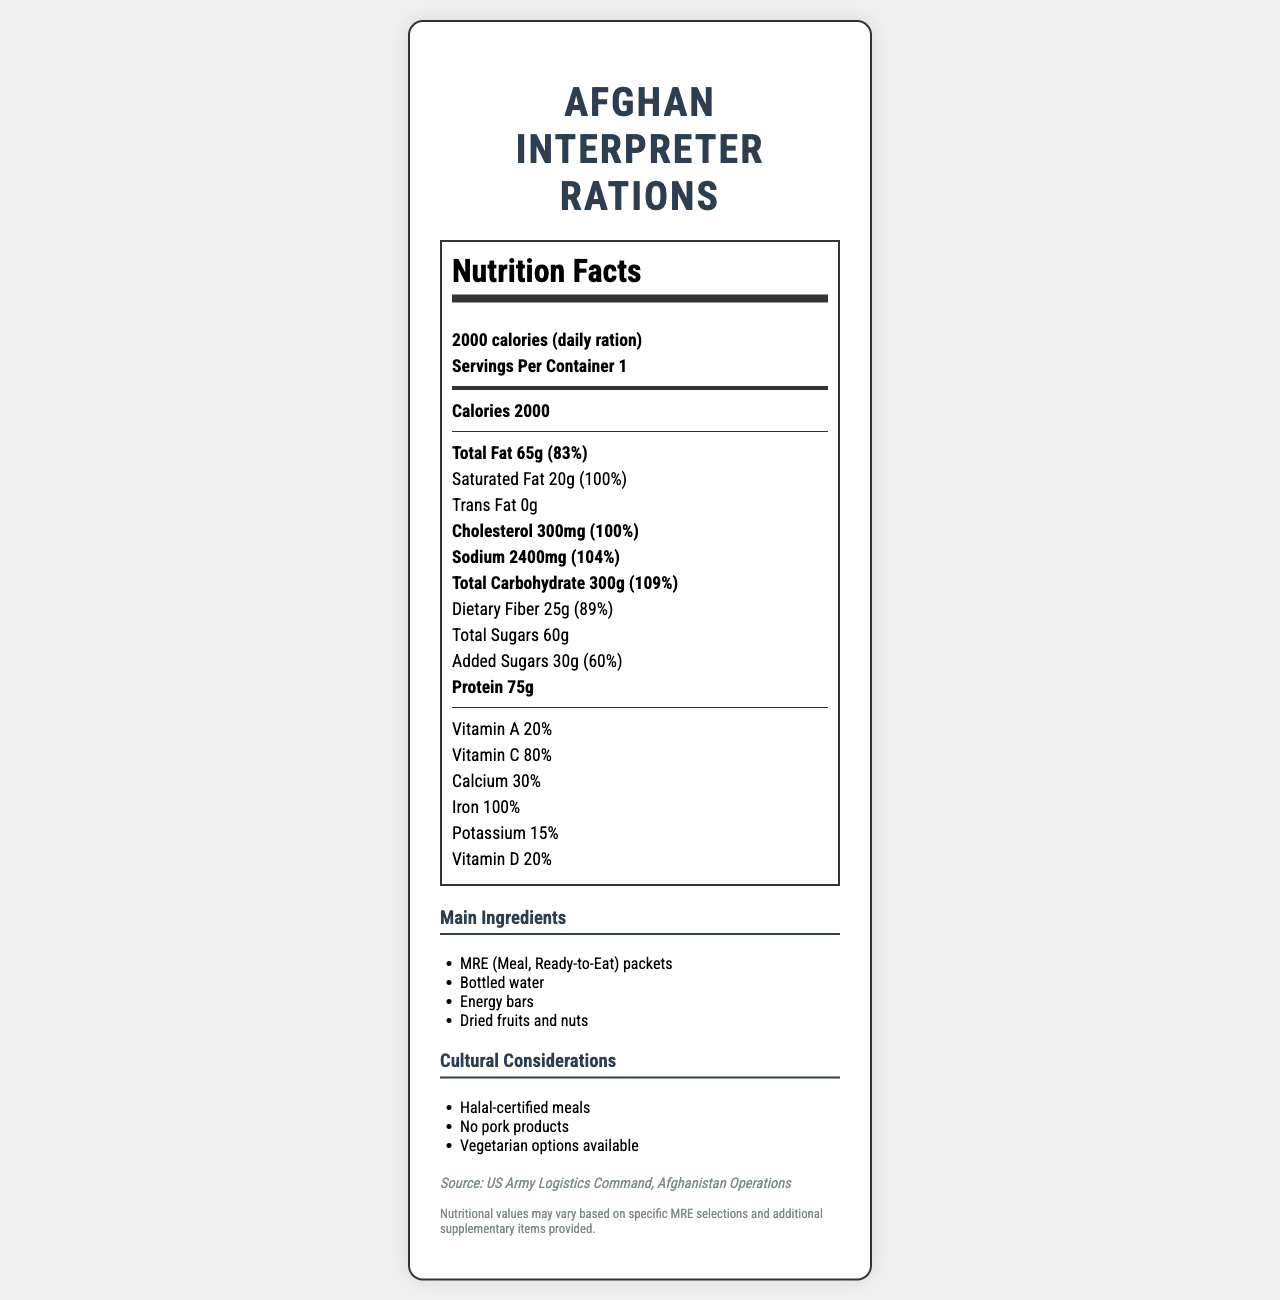what is the serving size? The serving size is clearly mentioned at the top of the nutrition label as "2000 calories (daily ration)".
Answer: 2000 calories (daily ration) how many calories are in one serving? The number of calories per serving is listed as 2000 in the nutrition facts section.
Answer: 2000 what is the percentage of daily value for total fat? The percentage of daily value for total fat is noted as 83% next to the amount of total fat.
Answer: 83% how much protein does the daily ration provide? The amount of protein provided by the daily ration is listed as 75 grams.
Answer: 75g which vitamin has the highest daily value percentage? Vitamin C has the highest daily value percentage, which is 80%.
Answer: Vitamin C what is the amount of total carbohydrate in the daily ration? The total carbohydrate amount is listed as 300 grams.
Answer: 300g which ingredient is not included in the main ingredients list? A. MRE packets B. Bottled water C. Fresh vegetables D. Dried fruits and nuts Fresh vegetables are not listed among the main ingredients; the list includes MRE packets, bottled water, energy bars, and dried fruits and nuts.
Answer: C. Fresh vegetables what cultural consideration has been made regarding dietary restrictions? A. Halal-certified meals B. Organic food C. Gluten-free options The document lists Halal-certified meals as one of the cultural considerations to cater to dietary restrictions.
Answer: A. Halal-certified meals is there any pork product included in the ration? One of the cultural considerations mentioned is "No pork products," indicating it is not included.
Answer: No describe the main idea of this document The document serves as a comprehensive overview of the nutritional and cultural aspects of the rations provided to Afghan interpreters, ensuring that their dietary needs and cultural preferences are met.
Answer: The document provides the nutrition facts for the daily rations provided to Afghan interpreters working with international forces. It details the serving size, caloric content, amounts, and daily percentages of various nutrients, lists the main ingredients, and highlights cultural considerations such as Halal-certified meals, absence of pork products, and vegetarian options. what is the daily value percentage for calcium? The daily value percentage for calcium is documented as 30%.
Answer: 30% how much added sugar is in one daily ration? The amount of added sugar is noted as 30 grams with a daily value percentage of 60%.
Answer: 30g how many servings are there per container? The document mentions that there is 1 serving per container.
Answer: 1 can the exact serving sizes for different MRE selections be determined from this label? The note states that nutritional values may vary based on specific MRE selections and supplementary items, meaning the exact serving sizes can't be determined from this label alone.
Answer: Not enough information which of the following nutrients has a daily value percentage over 100%? A. Iron B. Protein C. Vitamin D The daily value percentage of iron is noted as 100%, while Vitamin D and protein have lower percentages.
Answer: A. Iron is the dietary fiber amount close to the daily recommended intake? The dietary fiber amount is 25 grams, which corresponds to 89% of the daily value, indicating it is close to the recommended intake.
Answer: Yes 